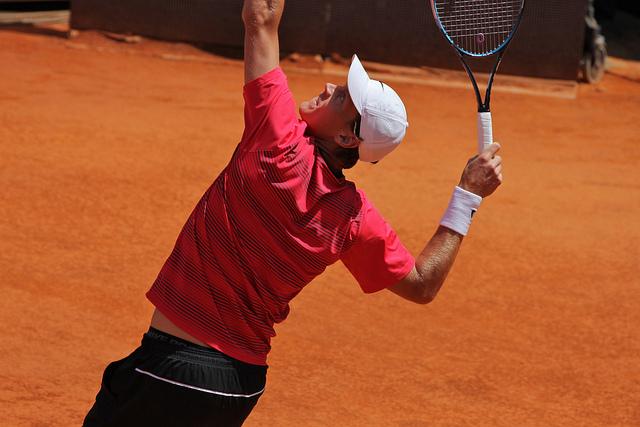How many stripes on the back of the player's shirt?
Give a very brief answer. 8. What color stripe runs along the shorts below the waistband?
Write a very short answer. White. Is the man wearing a white hat?
Answer briefly. Yes. 